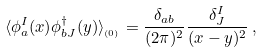Convert formula to latex. <formula><loc_0><loc_0><loc_500><loc_500>\langle \phi _ { a } ^ { I } ( x ) \phi _ { b J } ^ { \dagger } ( y ) \rangle _ { _ { ( 0 ) } } = \frac { \delta _ { a b } } { ( 2 \pi ) ^ { 2 } } \frac { \delta _ { J } ^ { I } } { ( x - y ) ^ { 2 } } \, ,</formula> 